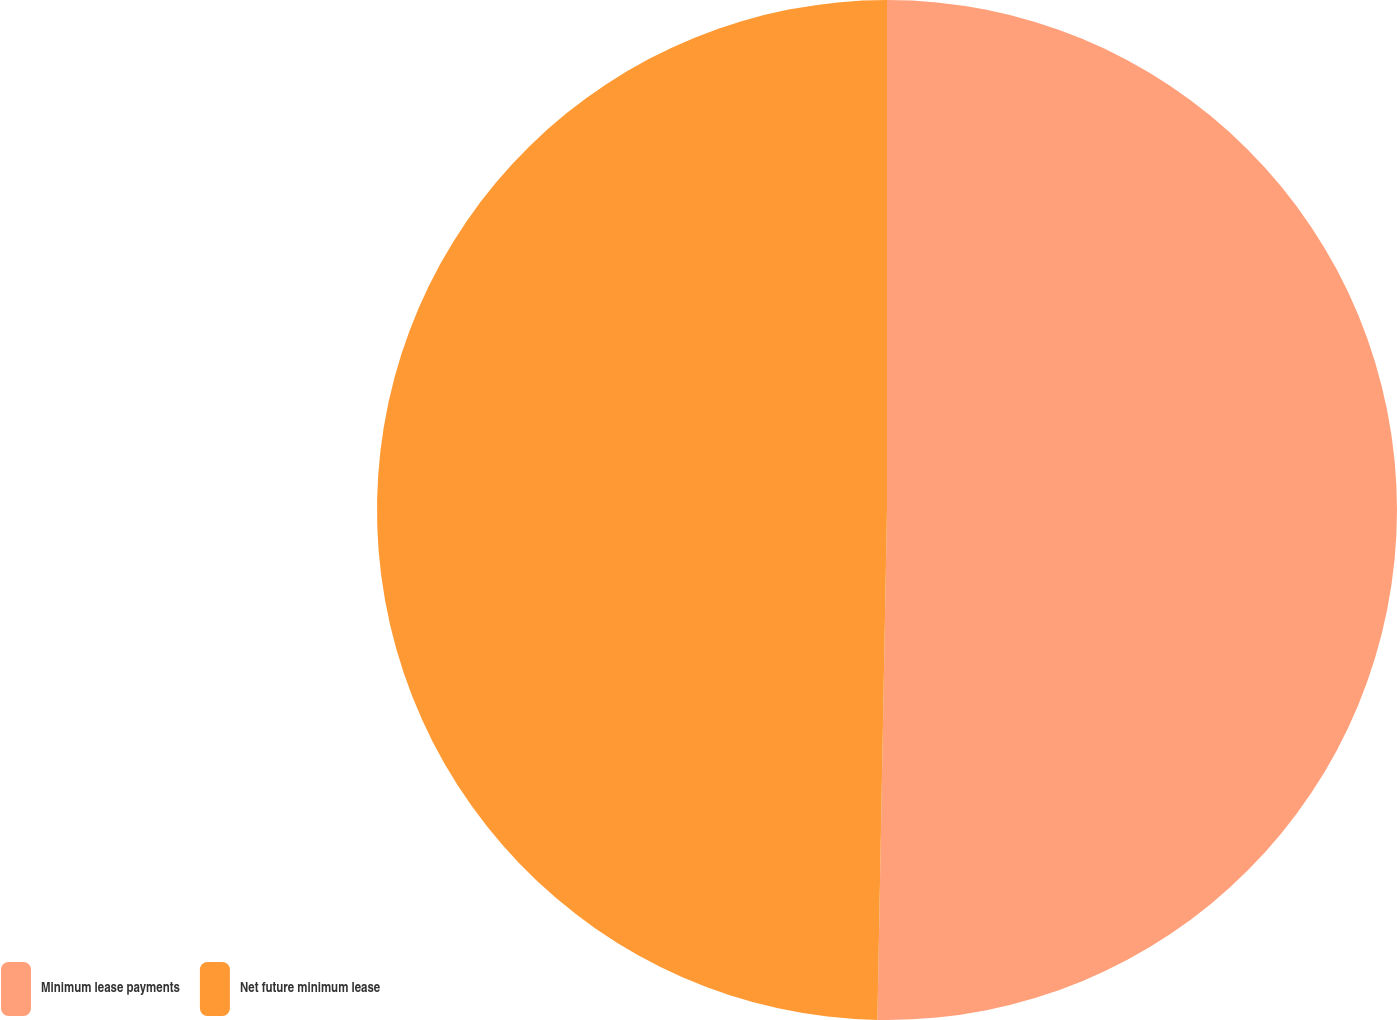Convert chart to OTSL. <chart><loc_0><loc_0><loc_500><loc_500><pie_chart><fcel>Minimum lease payments<fcel>Net future minimum lease<nl><fcel>50.3%<fcel>49.7%<nl></chart> 